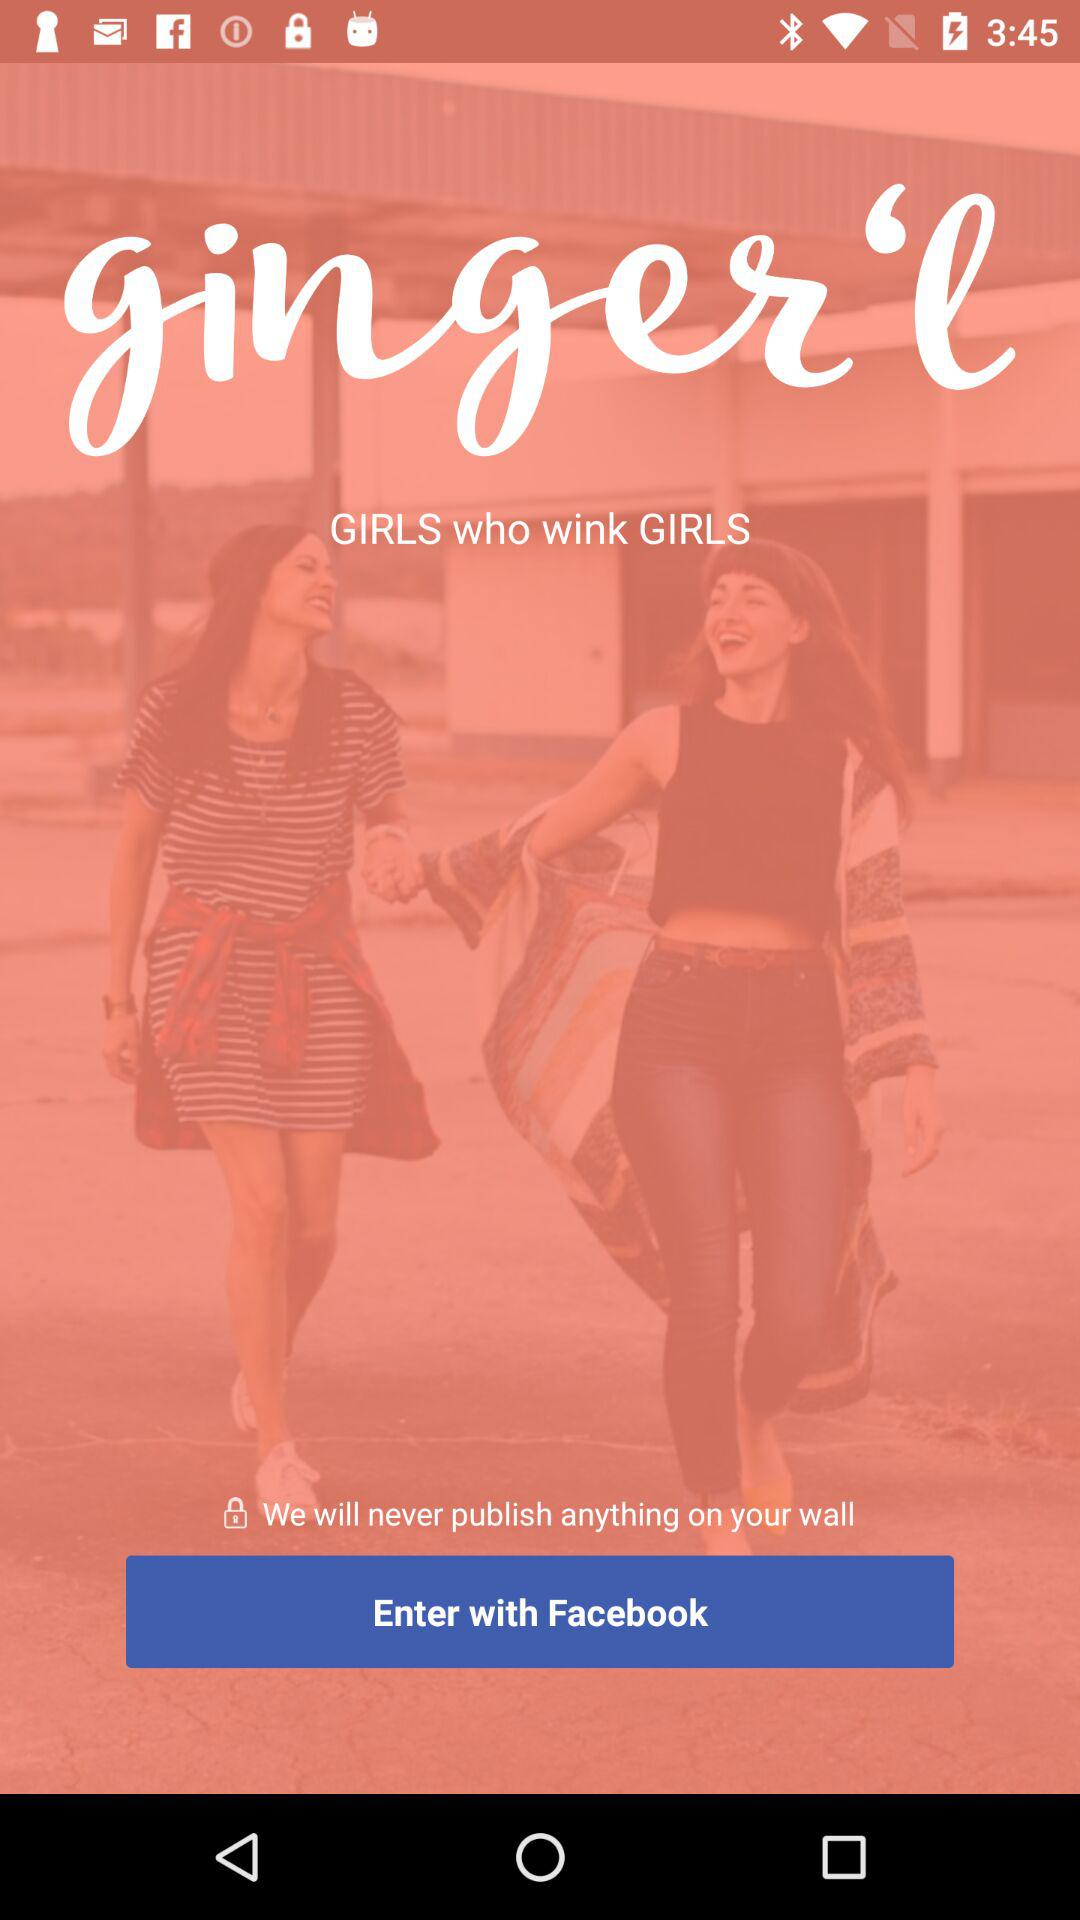With which application can the user continue? The user can continue with the "Facebook" application. 